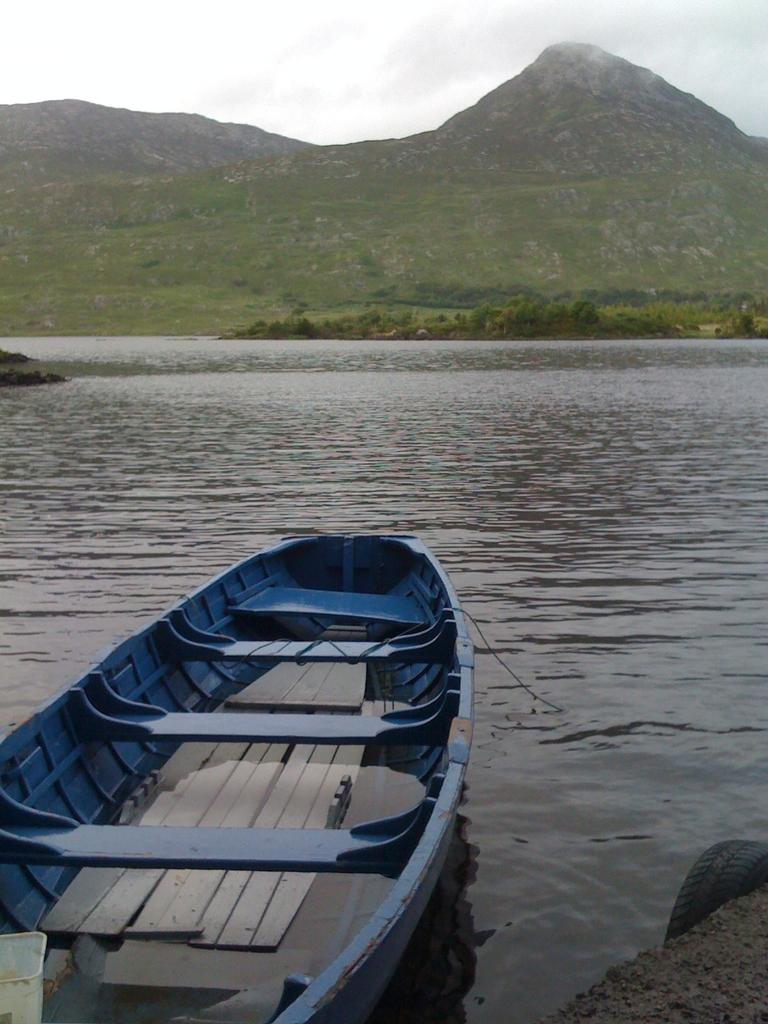What type of vehicle is in the image? There is a small blue boat in the image. Where is the boat located? The boat is on the river water. What can be seen in the background of the image? There is a huge mountain and trees in the background of the image. How many toes are visible on the boat in the image? There are no toes visible in the image, as it features a boat on the river water with a background of a huge mountain and trees. 